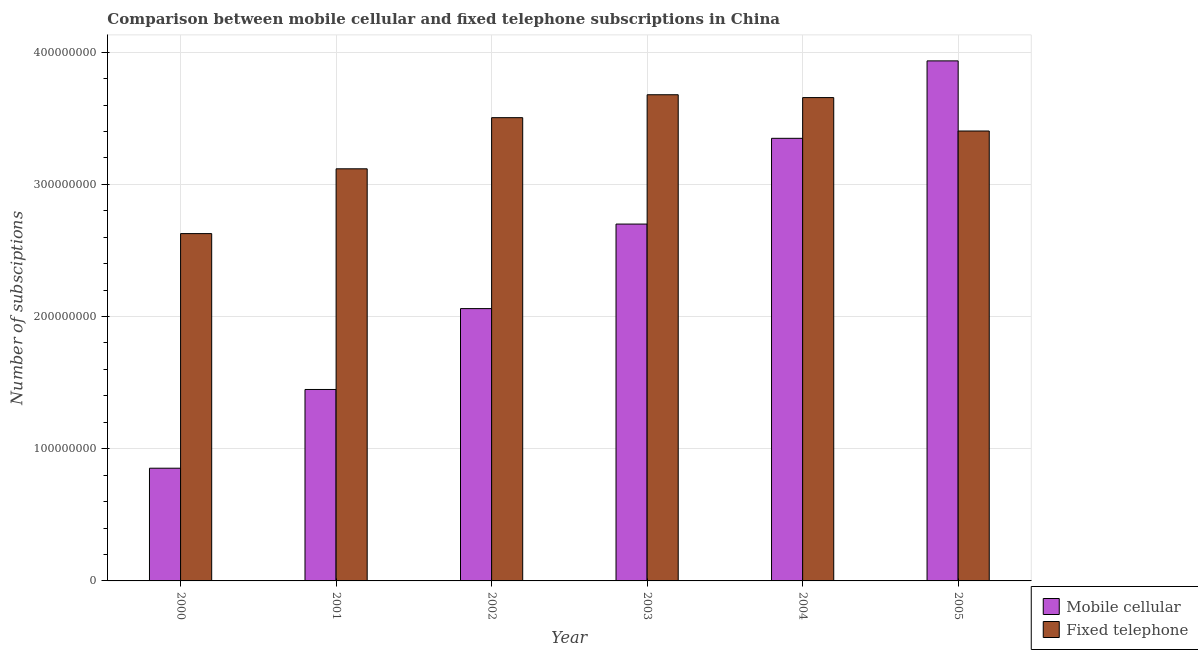Are the number of bars per tick equal to the number of legend labels?
Provide a short and direct response. Yes. Are the number of bars on each tick of the X-axis equal?
Offer a terse response. Yes. In how many cases, is the number of bars for a given year not equal to the number of legend labels?
Offer a terse response. 0. What is the number of mobile cellular subscriptions in 2000?
Give a very brief answer. 8.53e+07. Across all years, what is the maximum number of fixed telephone subscriptions?
Offer a very short reply. 3.68e+08. Across all years, what is the minimum number of fixed telephone subscriptions?
Your answer should be very brief. 2.63e+08. In which year was the number of fixed telephone subscriptions minimum?
Offer a terse response. 2000. What is the total number of mobile cellular subscriptions in the graph?
Provide a succinct answer. 1.43e+09. What is the difference between the number of mobile cellular subscriptions in 2003 and that in 2005?
Your response must be concise. -1.23e+08. What is the difference between the number of mobile cellular subscriptions in 2003 and the number of fixed telephone subscriptions in 2005?
Keep it short and to the point. -1.23e+08. What is the average number of fixed telephone subscriptions per year?
Your answer should be compact. 3.33e+08. What is the ratio of the number of fixed telephone subscriptions in 2000 to that in 2005?
Your response must be concise. 0.77. Is the number of fixed telephone subscriptions in 2002 less than that in 2003?
Provide a succinct answer. Yes. What is the difference between the highest and the second highest number of fixed telephone subscriptions?
Provide a succinct answer. 2.15e+06. What is the difference between the highest and the lowest number of mobile cellular subscriptions?
Keep it short and to the point. 3.08e+08. In how many years, is the number of fixed telephone subscriptions greater than the average number of fixed telephone subscriptions taken over all years?
Make the answer very short. 4. Is the sum of the number of fixed telephone subscriptions in 2002 and 2004 greater than the maximum number of mobile cellular subscriptions across all years?
Ensure brevity in your answer.  Yes. What does the 2nd bar from the left in 2005 represents?
Your answer should be very brief. Fixed telephone. What does the 2nd bar from the right in 2000 represents?
Offer a very short reply. Mobile cellular. Are all the bars in the graph horizontal?
Make the answer very short. No. Does the graph contain any zero values?
Give a very brief answer. No. Does the graph contain grids?
Keep it short and to the point. Yes. What is the title of the graph?
Your response must be concise. Comparison between mobile cellular and fixed telephone subscriptions in China. What is the label or title of the X-axis?
Make the answer very short. Year. What is the label or title of the Y-axis?
Give a very brief answer. Number of subsciptions. What is the Number of subsciptions of Mobile cellular in 2000?
Keep it short and to the point. 8.53e+07. What is the Number of subsciptions of Fixed telephone in 2000?
Your answer should be compact. 2.63e+08. What is the Number of subsciptions of Mobile cellular in 2001?
Make the answer very short. 1.45e+08. What is the Number of subsciptions in Fixed telephone in 2001?
Offer a very short reply. 3.12e+08. What is the Number of subsciptions of Mobile cellular in 2002?
Offer a very short reply. 2.06e+08. What is the Number of subsciptions of Fixed telephone in 2002?
Your answer should be compact. 3.50e+08. What is the Number of subsciptions in Mobile cellular in 2003?
Provide a short and direct response. 2.70e+08. What is the Number of subsciptions in Fixed telephone in 2003?
Ensure brevity in your answer.  3.68e+08. What is the Number of subsciptions of Mobile cellular in 2004?
Your answer should be very brief. 3.35e+08. What is the Number of subsciptions of Fixed telephone in 2004?
Provide a short and direct response. 3.66e+08. What is the Number of subsciptions of Mobile cellular in 2005?
Your response must be concise. 3.93e+08. What is the Number of subsciptions of Fixed telephone in 2005?
Your response must be concise. 3.40e+08. Across all years, what is the maximum Number of subsciptions of Mobile cellular?
Provide a succinct answer. 3.93e+08. Across all years, what is the maximum Number of subsciptions of Fixed telephone?
Ensure brevity in your answer.  3.68e+08. Across all years, what is the minimum Number of subsciptions in Mobile cellular?
Give a very brief answer. 8.53e+07. Across all years, what is the minimum Number of subsciptions of Fixed telephone?
Your response must be concise. 2.63e+08. What is the total Number of subsciptions in Mobile cellular in the graph?
Provide a short and direct response. 1.43e+09. What is the total Number of subsciptions of Fixed telephone in the graph?
Your answer should be very brief. 2.00e+09. What is the difference between the Number of subsciptions of Mobile cellular in 2000 and that in 2001?
Keep it short and to the point. -5.96e+07. What is the difference between the Number of subsciptions in Fixed telephone in 2000 and that in 2001?
Make the answer very short. -4.90e+07. What is the difference between the Number of subsciptions in Mobile cellular in 2000 and that in 2002?
Offer a terse response. -1.21e+08. What is the difference between the Number of subsciptions of Fixed telephone in 2000 and that in 2002?
Ensure brevity in your answer.  -8.77e+07. What is the difference between the Number of subsciptions of Mobile cellular in 2000 and that in 2003?
Keep it short and to the point. -1.85e+08. What is the difference between the Number of subsciptions in Fixed telephone in 2000 and that in 2003?
Provide a succinct answer. -1.05e+08. What is the difference between the Number of subsciptions of Mobile cellular in 2000 and that in 2004?
Your answer should be very brief. -2.50e+08. What is the difference between the Number of subsciptions of Fixed telephone in 2000 and that in 2004?
Ensure brevity in your answer.  -1.03e+08. What is the difference between the Number of subsciptions of Mobile cellular in 2000 and that in 2005?
Offer a terse response. -3.08e+08. What is the difference between the Number of subsciptions of Fixed telephone in 2000 and that in 2005?
Provide a short and direct response. -7.76e+07. What is the difference between the Number of subsciptions of Mobile cellular in 2001 and that in 2002?
Provide a short and direct response. -6.12e+07. What is the difference between the Number of subsciptions of Fixed telephone in 2001 and that in 2002?
Provide a succinct answer. -3.87e+07. What is the difference between the Number of subsciptions in Mobile cellular in 2001 and that in 2003?
Make the answer very short. -1.25e+08. What is the difference between the Number of subsciptions in Fixed telephone in 2001 and that in 2003?
Keep it short and to the point. -5.60e+07. What is the difference between the Number of subsciptions in Mobile cellular in 2001 and that in 2004?
Offer a terse response. -1.90e+08. What is the difference between the Number of subsciptions in Fixed telephone in 2001 and that in 2004?
Provide a short and direct response. -5.39e+07. What is the difference between the Number of subsciptions of Mobile cellular in 2001 and that in 2005?
Give a very brief answer. -2.49e+08. What is the difference between the Number of subsciptions of Fixed telephone in 2001 and that in 2005?
Your response must be concise. -2.86e+07. What is the difference between the Number of subsciptions of Mobile cellular in 2002 and that in 2003?
Ensure brevity in your answer.  -6.39e+07. What is the difference between the Number of subsciptions of Fixed telephone in 2002 and that in 2003?
Provide a short and direct response. -1.73e+07. What is the difference between the Number of subsciptions in Mobile cellular in 2002 and that in 2004?
Offer a very short reply. -1.29e+08. What is the difference between the Number of subsciptions in Fixed telephone in 2002 and that in 2004?
Offer a very short reply. -1.52e+07. What is the difference between the Number of subsciptions of Mobile cellular in 2002 and that in 2005?
Offer a terse response. -1.87e+08. What is the difference between the Number of subsciptions of Fixed telephone in 2002 and that in 2005?
Keep it short and to the point. 1.01e+07. What is the difference between the Number of subsciptions of Mobile cellular in 2003 and that in 2004?
Provide a succinct answer. -6.49e+07. What is the difference between the Number of subsciptions in Fixed telephone in 2003 and that in 2004?
Provide a short and direct response. 2.15e+06. What is the difference between the Number of subsciptions in Mobile cellular in 2003 and that in 2005?
Your response must be concise. -1.23e+08. What is the difference between the Number of subsciptions in Fixed telephone in 2003 and that in 2005?
Offer a very short reply. 2.74e+07. What is the difference between the Number of subsciptions of Mobile cellular in 2004 and that in 2005?
Your answer should be very brief. -5.86e+07. What is the difference between the Number of subsciptions of Fixed telephone in 2004 and that in 2005?
Your response must be concise. 2.53e+07. What is the difference between the Number of subsciptions of Mobile cellular in 2000 and the Number of subsciptions of Fixed telephone in 2001?
Ensure brevity in your answer.  -2.26e+08. What is the difference between the Number of subsciptions in Mobile cellular in 2000 and the Number of subsciptions in Fixed telephone in 2002?
Ensure brevity in your answer.  -2.65e+08. What is the difference between the Number of subsciptions in Mobile cellular in 2000 and the Number of subsciptions in Fixed telephone in 2003?
Your answer should be compact. -2.83e+08. What is the difference between the Number of subsciptions of Mobile cellular in 2000 and the Number of subsciptions of Fixed telephone in 2004?
Provide a succinct answer. -2.80e+08. What is the difference between the Number of subsciptions of Mobile cellular in 2000 and the Number of subsciptions of Fixed telephone in 2005?
Your response must be concise. -2.55e+08. What is the difference between the Number of subsciptions in Mobile cellular in 2001 and the Number of subsciptions in Fixed telephone in 2002?
Make the answer very short. -2.06e+08. What is the difference between the Number of subsciptions in Mobile cellular in 2001 and the Number of subsciptions in Fixed telephone in 2003?
Your answer should be very brief. -2.23e+08. What is the difference between the Number of subsciptions of Mobile cellular in 2001 and the Number of subsciptions of Fixed telephone in 2004?
Your response must be concise. -2.21e+08. What is the difference between the Number of subsciptions of Mobile cellular in 2001 and the Number of subsciptions of Fixed telephone in 2005?
Ensure brevity in your answer.  -1.96e+08. What is the difference between the Number of subsciptions of Mobile cellular in 2002 and the Number of subsciptions of Fixed telephone in 2003?
Make the answer very short. -1.62e+08. What is the difference between the Number of subsciptions of Mobile cellular in 2002 and the Number of subsciptions of Fixed telephone in 2004?
Provide a short and direct response. -1.60e+08. What is the difference between the Number of subsciptions of Mobile cellular in 2002 and the Number of subsciptions of Fixed telephone in 2005?
Ensure brevity in your answer.  -1.34e+08. What is the difference between the Number of subsciptions of Mobile cellular in 2003 and the Number of subsciptions of Fixed telephone in 2004?
Ensure brevity in your answer.  -9.57e+07. What is the difference between the Number of subsciptions in Mobile cellular in 2003 and the Number of subsciptions in Fixed telephone in 2005?
Provide a short and direct response. -7.04e+07. What is the difference between the Number of subsciptions of Mobile cellular in 2004 and the Number of subsciptions of Fixed telephone in 2005?
Provide a short and direct response. -5.54e+06. What is the average Number of subsciptions in Mobile cellular per year?
Provide a succinct answer. 2.39e+08. What is the average Number of subsciptions in Fixed telephone per year?
Ensure brevity in your answer.  3.33e+08. In the year 2000, what is the difference between the Number of subsciptions of Mobile cellular and Number of subsciptions of Fixed telephone?
Provide a succinct answer. -1.77e+08. In the year 2001, what is the difference between the Number of subsciptions of Mobile cellular and Number of subsciptions of Fixed telephone?
Your response must be concise. -1.67e+08. In the year 2002, what is the difference between the Number of subsciptions in Mobile cellular and Number of subsciptions in Fixed telephone?
Give a very brief answer. -1.44e+08. In the year 2003, what is the difference between the Number of subsciptions in Mobile cellular and Number of subsciptions in Fixed telephone?
Give a very brief answer. -9.78e+07. In the year 2004, what is the difference between the Number of subsciptions in Mobile cellular and Number of subsciptions in Fixed telephone?
Give a very brief answer. -3.08e+07. In the year 2005, what is the difference between the Number of subsciptions in Mobile cellular and Number of subsciptions in Fixed telephone?
Provide a succinct answer. 5.30e+07. What is the ratio of the Number of subsciptions in Mobile cellular in 2000 to that in 2001?
Your answer should be compact. 0.59. What is the ratio of the Number of subsciptions of Fixed telephone in 2000 to that in 2001?
Give a very brief answer. 0.84. What is the ratio of the Number of subsciptions in Mobile cellular in 2000 to that in 2002?
Provide a succinct answer. 0.41. What is the ratio of the Number of subsciptions in Fixed telephone in 2000 to that in 2002?
Provide a short and direct response. 0.75. What is the ratio of the Number of subsciptions of Mobile cellular in 2000 to that in 2003?
Give a very brief answer. 0.32. What is the ratio of the Number of subsciptions of Fixed telephone in 2000 to that in 2003?
Your answer should be very brief. 0.71. What is the ratio of the Number of subsciptions in Mobile cellular in 2000 to that in 2004?
Ensure brevity in your answer.  0.25. What is the ratio of the Number of subsciptions in Fixed telephone in 2000 to that in 2004?
Give a very brief answer. 0.72. What is the ratio of the Number of subsciptions in Mobile cellular in 2000 to that in 2005?
Give a very brief answer. 0.22. What is the ratio of the Number of subsciptions of Fixed telephone in 2000 to that in 2005?
Keep it short and to the point. 0.77. What is the ratio of the Number of subsciptions of Mobile cellular in 2001 to that in 2002?
Your response must be concise. 0.7. What is the ratio of the Number of subsciptions of Fixed telephone in 2001 to that in 2002?
Your answer should be compact. 0.89. What is the ratio of the Number of subsciptions in Mobile cellular in 2001 to that in 2003?
Offer a terse response. 0.54. What is the ratio of the Number of subsciptions of Fixed telephone in 2001 to that in 2003?
Keep it short and to the point. 0.85. What is the ratio of the Number of subsciptions in Mobile cellular in 2001 to that in 2004?
Your answer should be compact. 0.43. What is the ratio of the Number of subsciptions in Fixed telephone in 2001 to that in 2004?
Your answer should be compact. 0.85. What is the ratio of the Number of subsciptions in Mobile cellular in 2001 to that in 2005?
Your answer should be very brief. 0.37. What is the ratio of the Number of subsciptions in Fixed telephone in 2001 to that in 2005?
Your answer should be compact. 0.92. What is the ratio of the Number of subsciptions of Mobile cellular in 2002 to that in 2003?
Make the answer very short. 0.76. What is the ratio of the Number of subsciptions of Fixed telephone in 2002 to that in 2003?
Your answer should be very brief. 0.95. What is the ratio of the Number of subsciptions in Mobile cellular in 2002 to that in 2004?
Offer a very short reply. 0.62. What is the ratio of the Number of subsciptions in Fixed telephone in 2002 to that in 2004?
Give a very brief answer. 0.96. What is the ratio of the Number of subsciptions of Mobile cellular in 2002 to that in 2005?
Keep it short and to the point. 0.52. What is the ratio of the Number of subsciptions in Fixed telephone in 2002 to that in 2005?
Provide a short and direct response. 1.03. What is the ratio of the Number of subsciptions of Mobile cellular in 2003 to that in 2004?
Give a very brief answer. 0.81. What is the ratio of the Number of subsciptions of Fixed telephone in 2003 to that in 2004?
Give a very brief answer. 1.01. What is the ratio of the Number of subsciptions of Mobile cellular in 2003 to that in 2005?
Provide a succinct answer. 0.69. What is the ratio of the Number of subsciptions of Fixed telephone in 2003 to that in 2005?
Provide a short and direct response. 1.08. What is the ratio of the Number of subsciptions in Mobile cellular in 2004 to that in 2005?
Make the answer very short. 0.85. What is the ratio of the Number of subsciptions in Fixed telephone in 2004 to that in 2005?
Offer a terse response. 1.07. What is the difference between the highest and the second highest Number of subsciptions of Mobile cellular?
Your response must be concise. 5.86e+07. What is the difference between the highest and the second highest Number of subsciptions of Fixed telephone?
Keep it short and to the point. 2.15e+06. What is the difference between the highest and the lowest Number of subsciptions of Mobile cellular?
Give a very brief answer. 3.08e+08. What is the difference between the highest and the lowest Number of subsciptions in Fixed telephone?
Give a very brief answer. 1.05e+08. 